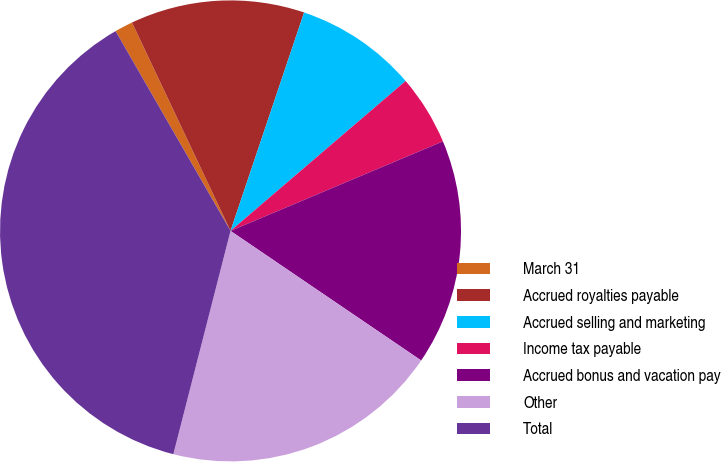Convert chart. <chart><loc_0><loc_0><loc_500><loc_500><pie_chart><fcel>March 31<fcel>Accrued royalties payable<fcel>Accrued selling and marketing<fcel>Income tax payable<fcel>Accrued bonus and vacation pay<fcel>Other<fcel>Total<nl><fcel>1.28%<fcel>12.2%<fcel>8.56%<fcel>4.92%<fcel>15.85%<fcel>19.49%<fcel>37.7%<nl></chart> 